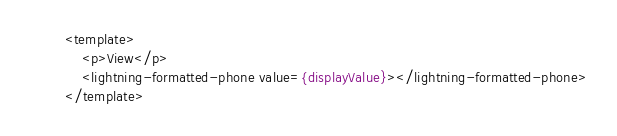<code> <loc_0><loc_0><loc_500><loc_500><_HTML_><template>
    <p>View</p>
    <lightning-formatted-phone value={displayValue}></lightning-formatted-phone>
</template>
</code> 